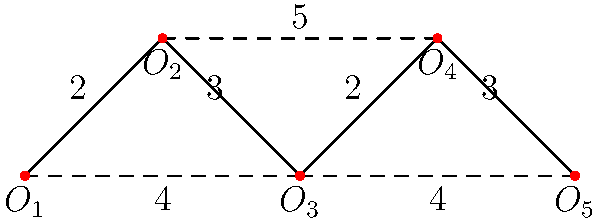Given a network of 5 office locations $(O_1, O_2, O_3, O_4, O_5)$ connected by wellness device data links, as shown in the diagram above, what is the minimum total cost to connect all offices while ensuring data can flow between any two offices? The numbers on the edges represent the cost (in thousands of dollars) to establish a direct link between two offices. To find the minimum total cost to connect all offices while ensuring data can flow between any two offices, we need to find the Minimum Spanning Tree (MST) of the given graph. We can use Kruskal's algorithm to solve this problem:

1. Sort all edges by weight (cost) in ascending order:
   $(O_1, O_2)$ and $(O_3, O_4)$: 2
   $(O_1, O_3)$ and $(O_3, O_5)$: 4
   $(O_2, O_3)$ and $(O_4, O_5)$: 3
   $(O_2, O_4)$: 5

2. Start with an empty set of edges and add edges in order of increasing weight, skipping any that would create a cycle:
   - Add $(O_1, O_2)$ and $(O_3, O_4)$: Cost = 2 + 2 = 4
   - Add $(O_2, O_3)$: Cost = 4 + 3 = 7
   - Add $(O_3, O_5)$: Cost = 7 + 4 = 11

3. After these steps, all offices are connected, and we have the Minimum Spanning Tree.

The total cost of the Minimum Spanning Tree is $11,000.
Answer: $11,000 